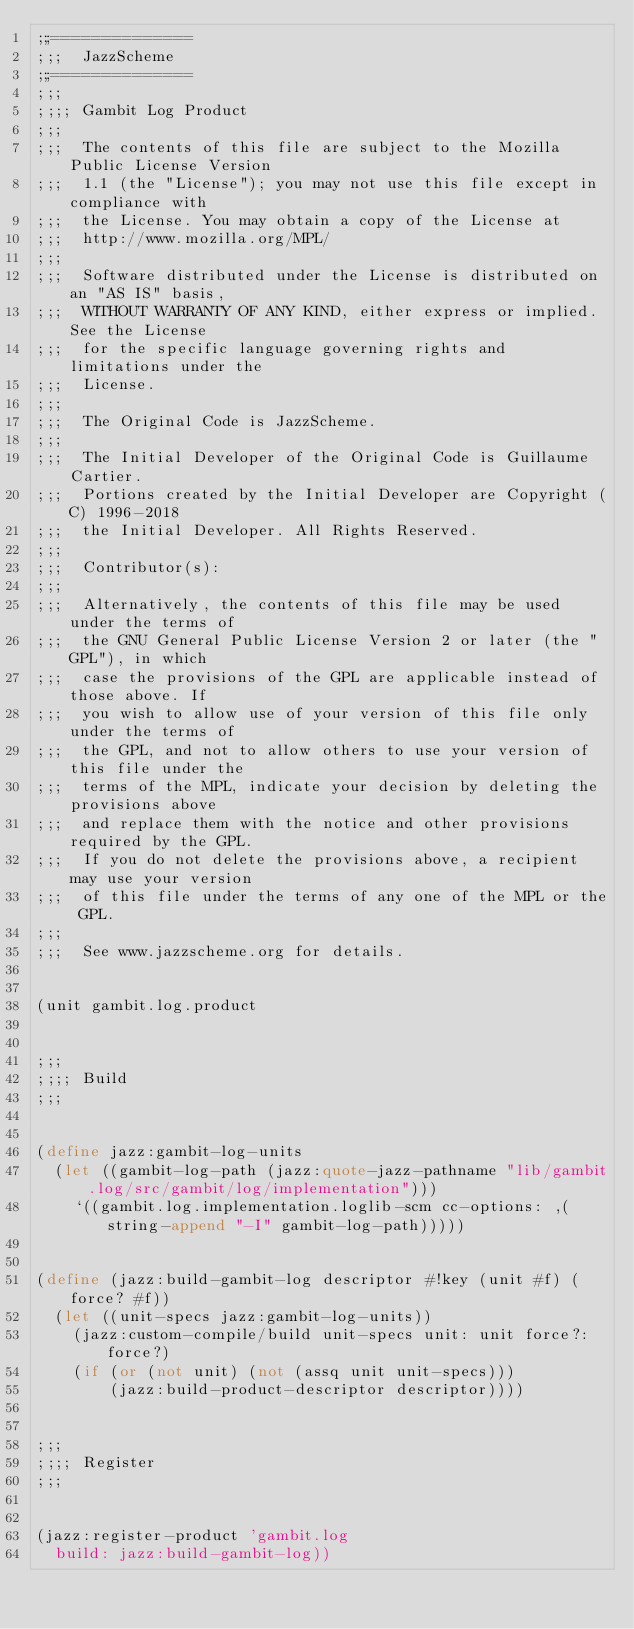Convert code to text. <code><loc_0><loc_0><loc_500><loc_500><_Scheme_>;;;==============
;;;  JazzScheme
;;;==============
;;;
;;;; Gambit Log Product
;;;
;;;  The contents of this file are subject to the Mozilla Public License Version
;;;  1.1 (the "License"); you may not use this file except in compliance with
;;;  the License. You may obtain a copy of the License at
;;;  http://www.mozilla.org/MPL/
;;;
;;;  Software distributed under the License is distributed on an "AS IS" basis,
;;;  WITHOUT WARRANTY OF ANY KIND, either express or implied. See the License
;;;  for the specific language governing rights and limitations under the
;;;  License.
;;;
;;;  The Original Code is JazzScheme.
;;;
;;;  The Initial Developer of the Original Code is Guillaume Cartier.
;;;  Portions created by the Initial Developer are Copyright (C) 1996-2018
;;;  the Initial Developer. All Rights Reserved.
;;;
;;;  Contributor(s):
;;;
;;;  Alternatively, the contents of this file may be used under the terms of
;;;  the GNU General Public License Version 2 or later (the "GPL"), in which
;;;  case the provisions of the GPL are applicable instead of those above. If
;;;  you wish to allow use of your version of this file only under the terms of
;;;  the GPL, and not to allow others to use your version of this file under the
;;;  terms of the MPL, indicate your decision by deleting the provisions above
;;;  and replace them with the notice and other provisions required by the GPL.
;;;  If you do not delete the provisions above, a recipient may use your version
;;;  of this file under the terms of any one of the MPL or the GPL.
;;;
;;;  See www.jazzscheme.org for details.


(unit gambit.log.product


;;;
;;;; Build
;;;


(define jazz:gambit-log-units
  (let ((gambit-log-path (jazz:quote-jazz-pathname "lib/gambit.log/src/gambit/log/implementation")))
    `((gambit.log.implementation.loglib-scm cc-options: ,(string-append "-I" gambit-log-path)))))


(define (jazz:build-gambit-log descriptor #!key (unit #f) (force? #f))
  (let ((unit-specs jazz:gambit-log-units))
    (jazz:custom-compile/build unit-specs unit: unit force?: force?)
    (if (or (not unit) (not (assq unit unit-specs)))
        (jazz:build-product-descriptor descriptor))))


;;;
;;;; Register
;;;


(jazz:register-product 'gambit.log
  build: jazz:build-gambit-log))
</code> 